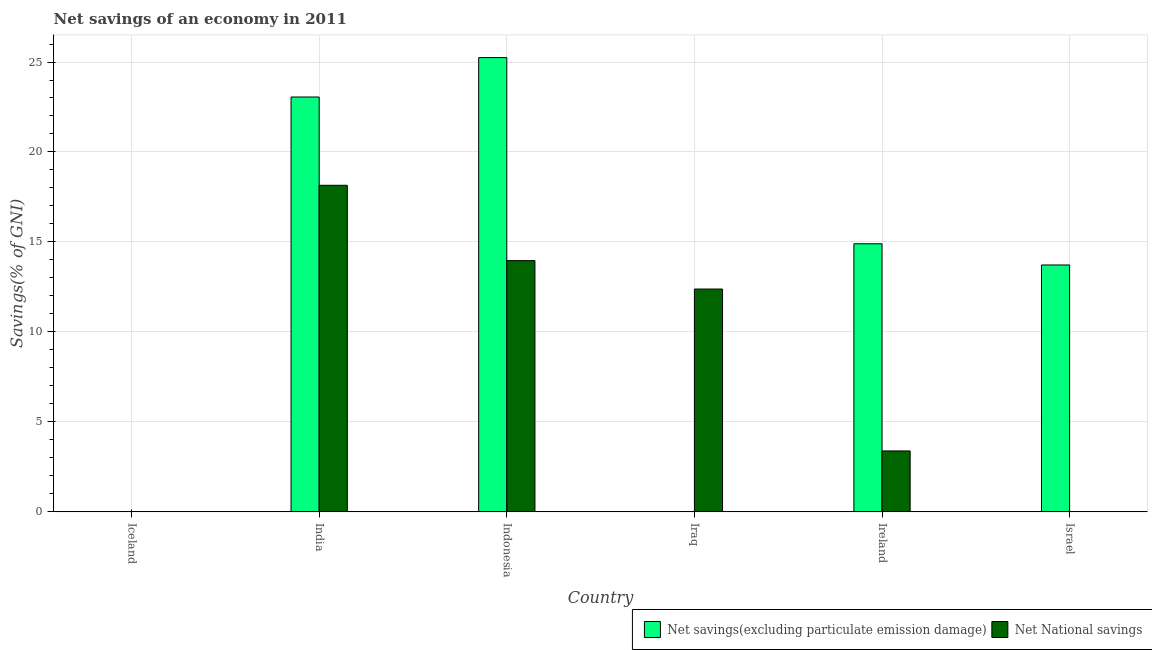How many different coloured bars are there?
Give a very brief answer. 2. Are the number of bars on each tick of the X-axis equal?
Provide a short and direct response. No. How many bars are there on the 6th tick from the left?
Offer a very short reply. 1. How many bars are there on the 4th tick from the right?
Give a very brief answer. 2. What is the label of the 3rd group of bars from the left?
Make the answer very short. Indonesia. In how many cases, is the number of bars for a given country not equal to the number of legend labels?
Make the answer very short. 3. Across all countries, what is the maximum net national savings?
Your answer should be very brief. 18.15. Across all countries, what is the minimum net savings(excluding particulate emission damage)?
Offer a very short reply. 0. In which country was the net national savings maximum?
Your answer should be very brief. India. What is the total net savings(excluding particulate emission damage) in the graph?
Your answer should be very brief. 76.92. What is the difference between the net national savings in Iraq and that in Ireland?
Your answer should be compact. 9. What is the difference between the net national savings in Indonesia and the net savings(excluding particulate emission damage) in India?
Make the answer very short. -9.09. What is the average net national savings per country?
Offer a very short reply. 7.98. What is the difference between the net national savings and net savings(excluding particulate emission damage) in Ireland?
Make the answer very short. -11.51. In how many countries, is the net savings(excluding particulate emission damage) greater than 25 %?
Give a very brief answer. 1. What is the ratio of the net savings(excluding particulate emission damage) in India to that in Ireland?
Offer a very short reply. 1.55. Is the net national savings in India less than that in Iraq?
Ensure brevity in your answer.  No. What is the difference between the highest and the second highest net savings(excluding particulate emission damage)?
Provide a succinct answer. 2.19. What is the difference between the highest and the lowest net savings(excluding particulate emission damage)?
Your answer should be very brief. 25.25. How many bars are there?
Make the answer very short. 8. How many countries are there in the graph?
Your answer should be compact. 6. What is the difference between two consecutive major ticks on the Y-axis?
Offer a terse response. 5. Are the values on the major ticks of Y-axis written in scientific E-notation?
Your answer should be compact. No. Where does the legend appear in the graph?
Give a very brief answer. Bottom right. How are the legend labels stacked?
Ensure brevity in your answer.  Horizontal. What is the title of the graph?
Your answer should be compact. Net savings of an economy in 2011. Does "International Tourists" appear as one of the legend labels in the graph?
Keep it short and to the point. No. What is the label or title of the X-axis?
Make the answer very short. Country. What is the label or title of the Y-axis?
Your answer should be very brief. Savings(% of GNI). What is the Savings(% of GNI) of Net savings(excluding particulate emission damage) in India?
Ensure brevity in your answer.  23.05. What is the Savings(% of GNI) of Net National savings in India?
Keep it short and to the point. 18.15. What is the Savings(% of GNI) in Net savings(excluding particulate emission damage) in Indonesia?
Give a very brief answer. 25.25. What is the Savings(% of GNI) in Net National savings in Indonesia?
Your response must be concise. 13.96. What is the Savings(% of GNI) of Net National savings in Iraq?
Keep it short and to the point. 12.38. What is the Savings(% of GNI) in Net savings(excluding particulate emission damage) in Ireland?
Your response must be concise. 14.9. What is the Savings(% of GNI) in Net National savings in Ireland?
Give a very brief answer. 3.39. What is the Savings(% of GNI) of Net savings(excluding particulate emission damage) in Israel?
Your answer should be very brief. 13.72. Across all countries, what is the maximum Savings(% of GNI) of Net savings(excluding particulate emission damage)?
Offer a terse response. 25.25. Across all countries, what is the maximum Savings(% of GNI) of Net National savings?
Make the answer very short. 18.15. Across all countries, what is the minimum Savings(% of GNI) of Net savings(excluding particulate emission damage)?
Your answer should be very brief. 0. What is the total Savings(% of GNI) in Net savings(excluding particulate emission damage) in the graph?
Make the answer very short. 76.92. What is the total Savings(% of GNI) in Net National savings in the graph?
Make the answer very short. 47.88. What is the difference between the Savings(% of GNI) of Net savings(excluding particulate emission damage) in India and that in Indonesia?
Your response must be concise. -2.19. What is the difference between the Savings(% of GNI) in Net National savings in India and that in Indonesia?
Provide a short and direct response. 4.19. What is the difference between the Savings(% of GNI) in Net National savings in India and that in Iraq?
Give a very brief answer. 5.77. What is the difference between the Savings(% of GNI) in Net savings(excluding particulate emission damage) in India and that in Ireland?
Give a very brief answer. 8.16. What is the difference between the Savings(% of GNI) of Net National savings in India and that in Ireland?
Give a very brief answer. 14.76. What is the difference between the Savings(% of GNI) in Net savings(excluding particulate emission damage) in India and that in Israel?
Keep it short and to the point. 9.33. What is the difference between the Savings(% of GNI) of Net National savings in Indonesia and that in Iraq?
Provide a succinct answer. 1.58. What is the difference between the Savings(% of GNI) in Net savings(excluding particulate emission damage) in Indonesia and that in Ireland?
Offer a terse response. 10.35. What is the difference between the Savings(% of GNI) of Net National savings in Indonesia and that in Ireland?
Ensure brevity in your answer.  10.58. What is the difference between the Savings(% of GNI) of Net savings(excluding particulate emission damage) in Indonesia and that in Israel?
Your answer should be very brief. 11.53. What is the difference between the Savings(% of GNI) of Net National savings in Iraq and that in Ireland?
Make the answer very short. 9. What is the difference between the Savings(% of GNI) of Net savings(excluding particulate emission damage) in Ireland and that in Israel?
Offer a very short reply. 1.18. What is the difference between the Savings(% of GNI) in Net savings(excluding particulate emission damage) in India and the Savings(% of GNI) in Net National savings in Indonesia?
Offer a very short reply. 9.09. What is the difference between the Savings(% of GNI) in Net savings(excluding particulate emission damage) in India and the Savings(% of GNI) in Net National savings in Iraq?
Offer a terse response. 10.67. What is the difference between the Savings(% of GNI) of Net savings(excluding particulate emission damage) in India and the Savings(% of GNI) of Net National savings in Ireland?
Your answer should be compact. 19.67. What is the difference between the Savings(% of GNI) in Net savings(excluding particulate emission damage) in Indonesia and the Savings(% of GNI) in Net National savings in Iraq?
Ensure brevity in your answer.  12.86. What is the difference between the Savings(% of GNI) of Net savings(excluding particulate emission damage) in Indonesia and the Savings(% of GNI) of Net National savings in Ireland?
Provide a succinct answer. 21.86. What is the average Savings(% of GNI) in Net savings(excluding particulate emission damage) per country?
Give a very brief answer. 12.82. What is the average Savings(% of GNI) in Net National savings per country?
Keep it short and to the point. 7.98. What is the difference between the Savings(% of GNI) of Net savings(excluding particulate emission damage) and Savings(% of GNI) of Net National savings in India?
Provide a short and direct response. 4.91. What is the difference between the Savings(% of GNI) of Net savings(excluding particulate emission damage) and Savings(% of GNI) of Net National savings in Indonesia?
Ensure brevity in your answer.  11.28. What is the difference between the Savings(% of GNI) in Net savings(excluding particulate emission damage) and Savings(% of GNI) in Net National savings in Ireland?
Your answer should be compact. 11.51. What is the ratio of the Savings(% of GNI) in Net savings(excluding particulate emission damage) in India to that in Indonesia?
Make the answer very short. 0.91. What is the ratio of the Savings(% of GNI) in Net National savings in India to that in Indonesia?
Keep it short and to the point. 1.3. What is the ratio of the Savings(% of GNI) of Net National savings in India to that in Iraq?
Your answer should be compact. 1.47. What is the ratio of the Savings(% of GNI) in Net savings(excluding particulate emission damage) in India to that in Ireland?
Your answer should be very brief. 1.55. What is the ratio of the Savings(% of GNI) in Net National savings in India to that in Ireland?
Make the answer very short. 5.36. What is the ratio of the Savings(% of GNI) in Net savings(excluding particulate emission damage) in India to that in Israel?
Offer a very short reply. 1.68. What is the ratio of the Savings(% of GNI) in Net National savings in Indonesia to that in Iraq?
Ensure brevity in your answer.  1.13. What is the ratio of the Savings(% of GNI) of Net savings(excluding particulate emission damage) in Indonesia to that in Ireland?
Give a very brief answer. 1.69. What is the ratio of the Savings(% of GNI) in Net National savings in Indonesia to that in Ireland?
Provide a succinct answer. 4.12. What is the ratio of the Savings(% of GNI) in Net savings(excluding particulate emission damage) in Indonesia to that in Israel?
Your answer should be compact. 1.84. What is the ratio of the Savings(% of GNI) in Net National savings in Iraq to that in Ireland?
Offer a terse response. 3.66. What is the ratio of the Savings(% of GNI) in Net savings(excluding particulate emission damage) in Ireland to that in Israel?
Offer a very short reply. 1.09. What is the difference between the highest and the second highest Savings(% of GNI) in Net savings(excluding particulate emission damage)?
Provide a succinct answer. 2.19. What is the difference between the highest and the second highest Savings(% of GNI) of Net National savings?
Provide a short and direct response. 4.19. What is the difference between the highest and the lowest Savings(% of GNI) in Net savings(excluding particulate emission damage)?
Your response must be concise. 25.25. What is the difference between the highest and the lowest Savings(% of GNI) in Net National savings?
Offer a very short reply. 18.15. 